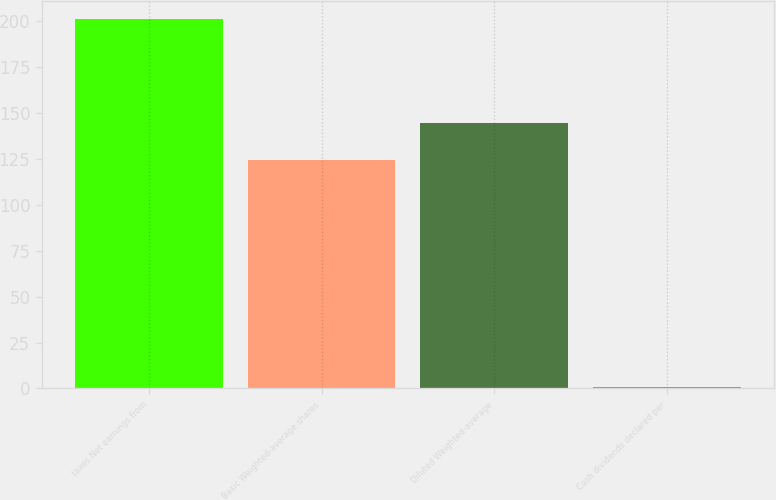Convert chart. <chart><loc_0><loc_0><loc_500><loc_500><bar_chart><fcel>taxes Net earnings from<fcel>Basic Weighted-average shares<fcel>Diluted Weighted-average<fcel>Cash dividends declared per<nl><fcel>200.9<fcel>124.1<fcel>144.13<fcel>0.64<nl></chart> 